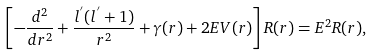<formula> <loc_0><loc_0><loc_500><loc_500>\left [ - \frac { d ^ { 2 } } { d r ^ { 2 } } + \frac { l ^ { ^ { \prime } } ( l ^ { ^ { \prime } } + 1 ) } { r ^ { 2 } } + \gamma ( r ) + 2 E V ( r ) \right ] R ( r ) = E ^ { 2 } R ( r ) ,</formula> 